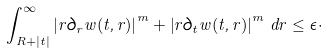<formula> <loc_0><loc_0><loc_500><loc_500>\int _ { R + | t | } ^ { \infty } \left | r \partial _ { r } w ( t , r ) \right | ^ { m } + \left | r \partial _ { t } w ( t , r ) \right | ^ { m } \, d r \leq \epsilon \cdot</formula> 